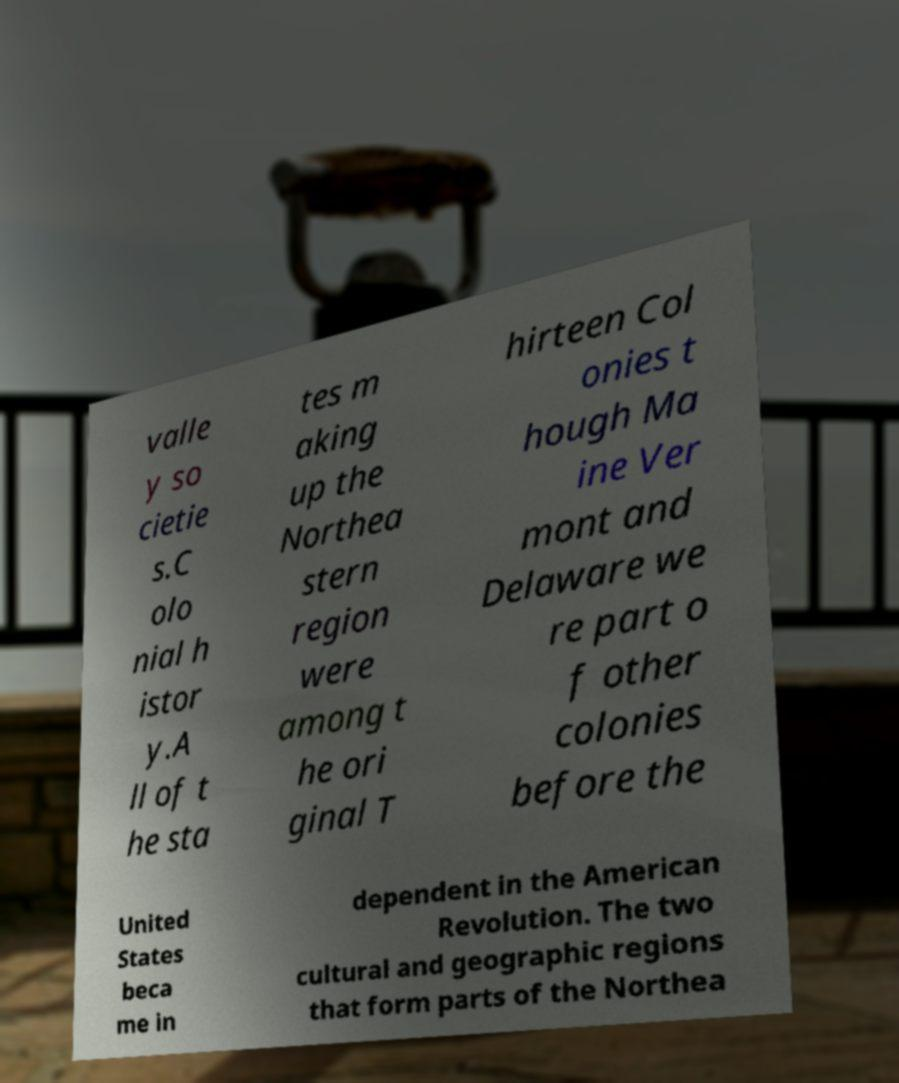Please identify and transcribe the text found in this image. valle y so cietie s.C olo nial h istor y.A ll of t he sta tes m aking up the Northea stern region were among t he ori ginal T hirteen Col onies t hough Ma ine Ver mont and Delaware we re part o f other colonies before the United States beca me in dependent in the American Revolution. The two cultural and geographic regions that form parts of the Northea 